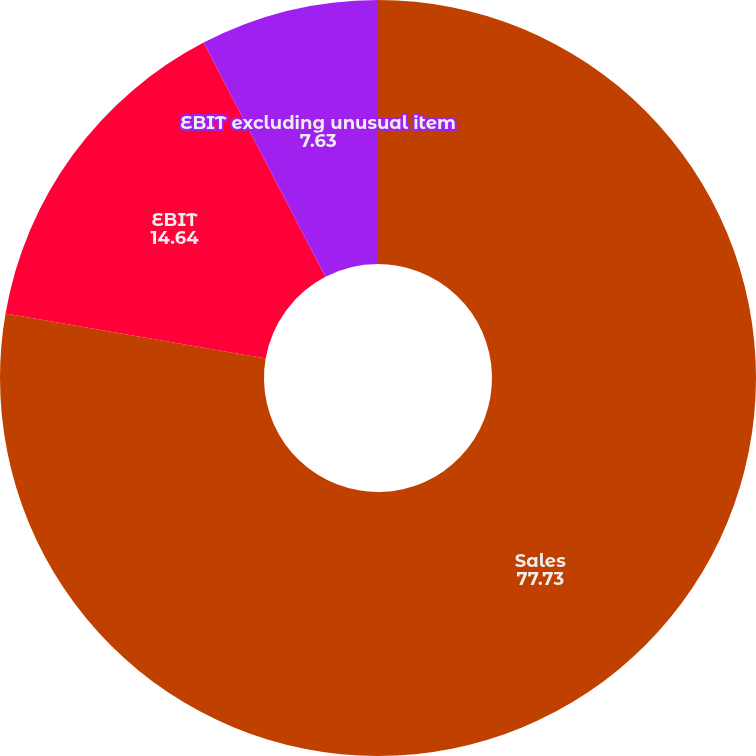Convert chart. <chart><loc_0><loc_0><loc_500><loc_500><pie_chart><fcel>Sales<fcel>EBIT<fcel>EBIT excluding unusual item<nl><fcel>77.73%<fcel>14.64%<fcel>7.63%<nl></chart> 